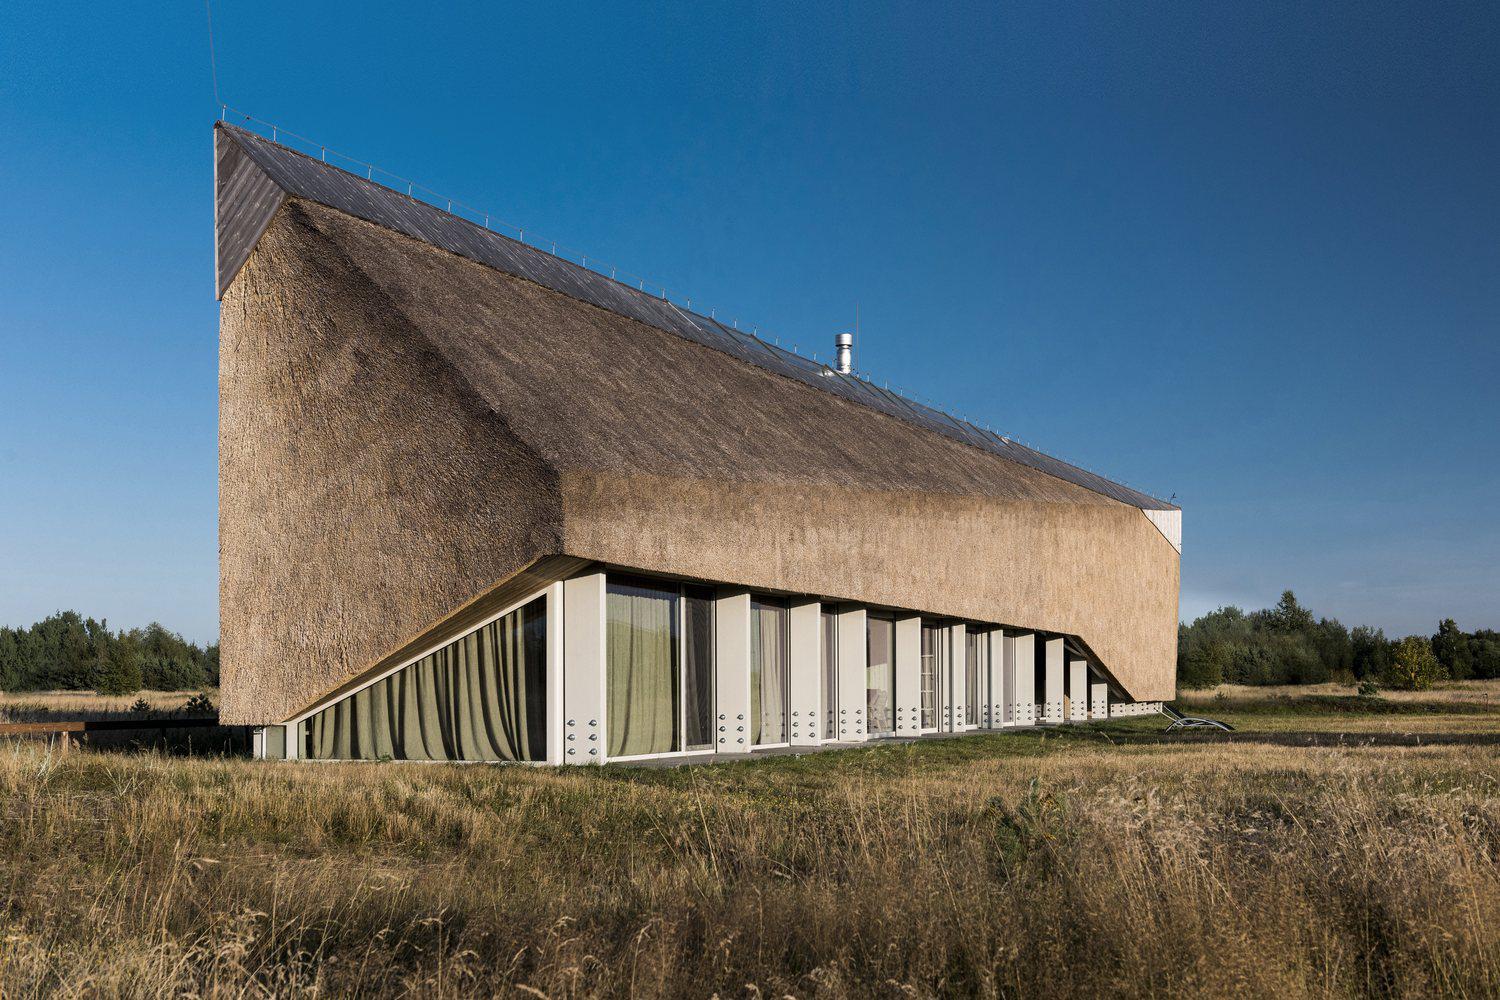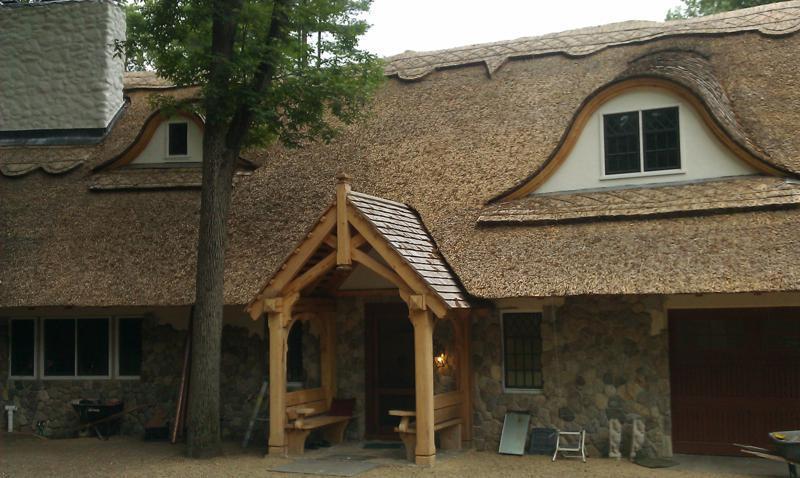The first image is the image on the left, the second image is the image on the right. For the images displayed, is the sentence "In at least one image there is a house with at least 3 white framed windows and the house and chimney are put together by brick." factually correct? Answer yes or no. No. 